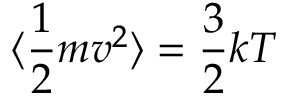Convert formula to latex. <formula><loc_0><loc_0><loc_500><loc_500>\langle \frac { 1 } { 2 } m v ^ { 2 } \rangle = \frac { 3 } { 2 } k T</formula> 